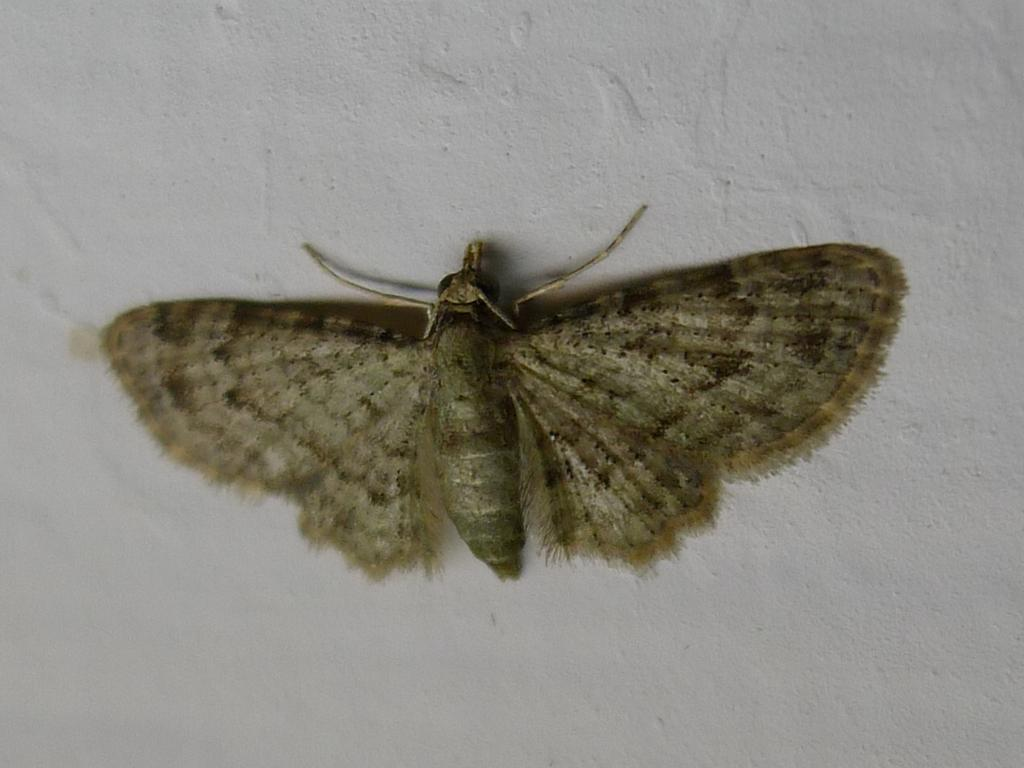What type of creature is present in the image? There is an insect in the image. What is the background or surface on which the insect is located? The insect is on a white surface. What is the price of the vase in the image? There is no vase present in the image, so it is not possible to determine the price of a vase. 